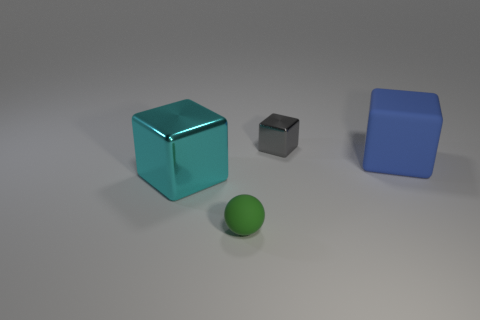Is the number of spheres to the left of the cyan block the same as the number of large matte things to the right of the matte block?
Offer a terse response. Yes. What is the material of the other big cyan thing that is the same shape as the large rubber thing?
Offer a terse response. Metal. The small thing to the left of the metal block behind the shiny block in front of the small gray metal block is what shape?
Provide a succinct answer. Sphere. Are there more small objects in front of the gray metallic block than cyan metal objects?
Offer a very short reply. No. There is a small metallic object that is behind the green rubber ball; is it the same shape as the cyan object?
Offer a terse response. Yes. What is the large cube that is left of the gray object made of?
Offer a very short reply. Metal. How many large cyan shiny objects have the same shape as the large blue matte object?
Keep it short and to the point. 1. What material is the small thing behind the block in front of the blue cube made of?
Your response must be concise. Metal. Is there a small gray block that has the same material as the ball?
Give a very brief answer. No. What is the shape of the cyan metallic object?
Provide a short and direct response. Cube. 